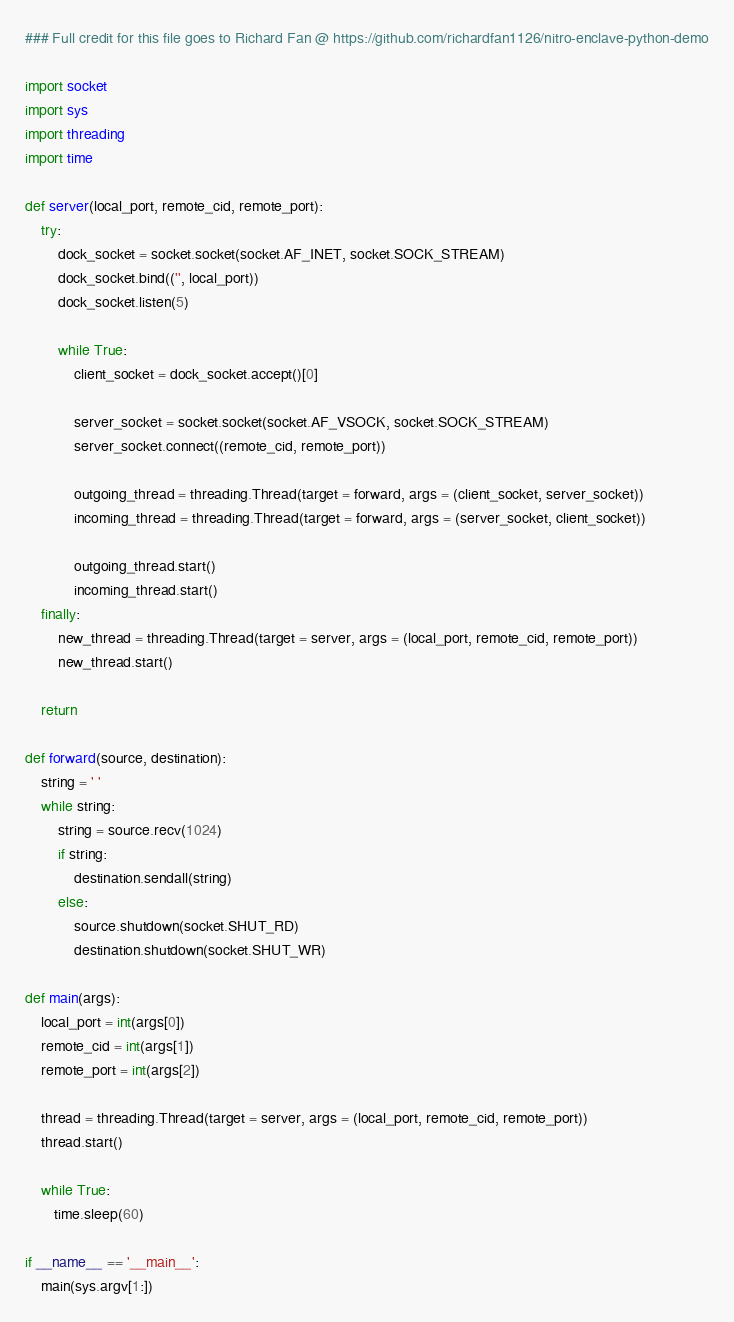<code> <loc_0><loc_0><loc_500><loc_500><_Python_>### Full credit for this file goes to Richard Fan @ https://github.com/richardfan1126/nitro-enclave-python-demo

import socket
import sys
import threading
import time

def server(local_port, remote_cid, remote_port):
    try:
        dock_socket = socket.socket(socket.AF_INET, socket.SOCK_STREAM)
        dock_socket.bind(('', local_port))
        dock_socket.listen(5)

        while True:
            client_socket = dock_socket.accept()[0]

            server_socket = socket.socket(socket.AF_VSOCK, socket.SOCK_STREAM)
            server_socket.connect((remote_cid, remote_port))

            outgoing_thread = threading.Thread(target = forward, args = (client_socket, server_socket))
            incoming_thread = threading.Thread(target = forward, args = (server_socket, client_socket))

            outgoing_thread.start()
            incoming_thread.start()
    finally:
        new_thread = threading.Thread(target = server, args = (local_port, remote_cid, remote_port))
        new_thread.start()
    
    return

def forward(source, destination):
    string = ' '
    while string:
        string = source.recv(1024)
        if string:
            destination.sendall(string)
        else:
            source.shutdown(socket.SHUT_RD)
            destination.shutdown(socket.SHUT_WR)

def main(args):
    local_port = int(args[0])
    remote_cid = int(args[1])
    remote_port = int(args[2])

    thread = threading.Thread(target = server, args = (local_port, remote_cid, remote_port))
    thread.start()

    while True:
       time.sleep(60)

if __name__ == '__main__':
    main(sys.argv[1:])
</code> 